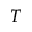Convert formula to latex. <formula><loc_0><loc_0><loc_500><loc_500>T</formula> 